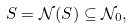Convert formula to latex. <formula><loc_0><loc_0><loc_500><loc_500>S = \mathcal { N } ( S ) \subseteq \mathcal { N } _ { 0 } ,</formula> 